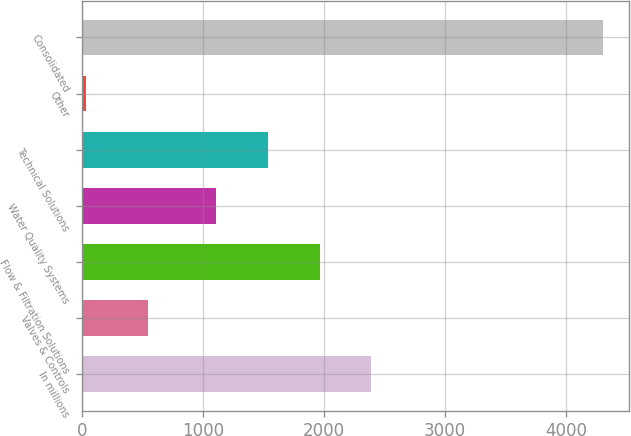<chart> <loc_0><loc_0><loc_500><loc_500><bar_chart><fcel>In millions<fcel>Valves & Controls<fcel>Flow & Filtration Solutions<fcel>Water Quality Systems<fcel>Technical Solutions<fcel>Other<fcel>Consolidated<nl><fcel>2392.04<fcel>540.3<fcel>1964.06<fcel>1108.1<fcel>1536.08<fcel>27<fcel>4306.8<nl></chart> 